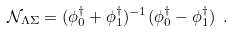Convert formula to latex. <formula><loc_0><loc_0><loc_500><loc_500>\mathcal { N } _ { \Lambda \Sigma } = ( \phi _ { 0 } ^ { \dag } + \phi _ { 1 } ^ { \dag } ) ^ { - 1 } ( \phi _ { 0 } ^ { \dag } - \phi _ { 1 } ^ { \dag } ) \ .</formula> 